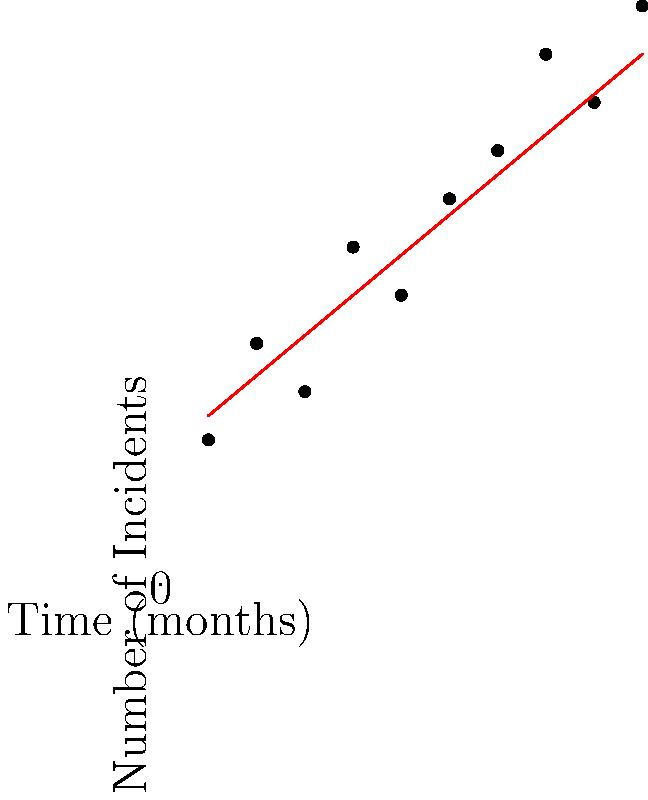Based on the scatter plot of food safety incidents over time, calculate the probability of having more than 10 incidents in the next month (month 11). Assume a linear trend and normally distributed residuals with a standard deviation of 1.5. To solve this problem, we'll follow these steps:

1. Determine the linear trend equation:
   We can estimate the trend line equation as $y = mx + b$
   From the graph, we can approximate $m \approx 0.8$ and $b \approx 3$
   So, the trend line equation is $y = 0.8x + 3$

2. Predict the expected number of incidents for month 11:
   $y = 0.8(11) + 3 = 11.8$

3. Calculate the z-score for more than 10 incidents:
   $z = \frac{x - \mu}{\sigma} = \frac{10 - 11.8}{1.5} = -1.2$

4. Find the probability using the standard normal distribution:
   $P(X > 10) = 1 - P(X \leq 10) = 1 - \Phi(-1.2)$
   
   Where $\Phi$ is the cumulative distribution function of the standard normal distribution.

5. Using a standard normal table or calculator:
   $\Phi(-1.2) \approx 0.1151$

6. Therefore, $P(X > 10) = 1 - 0.1151 = 0.8849$
Answer: 0.8849 or 88.49% 